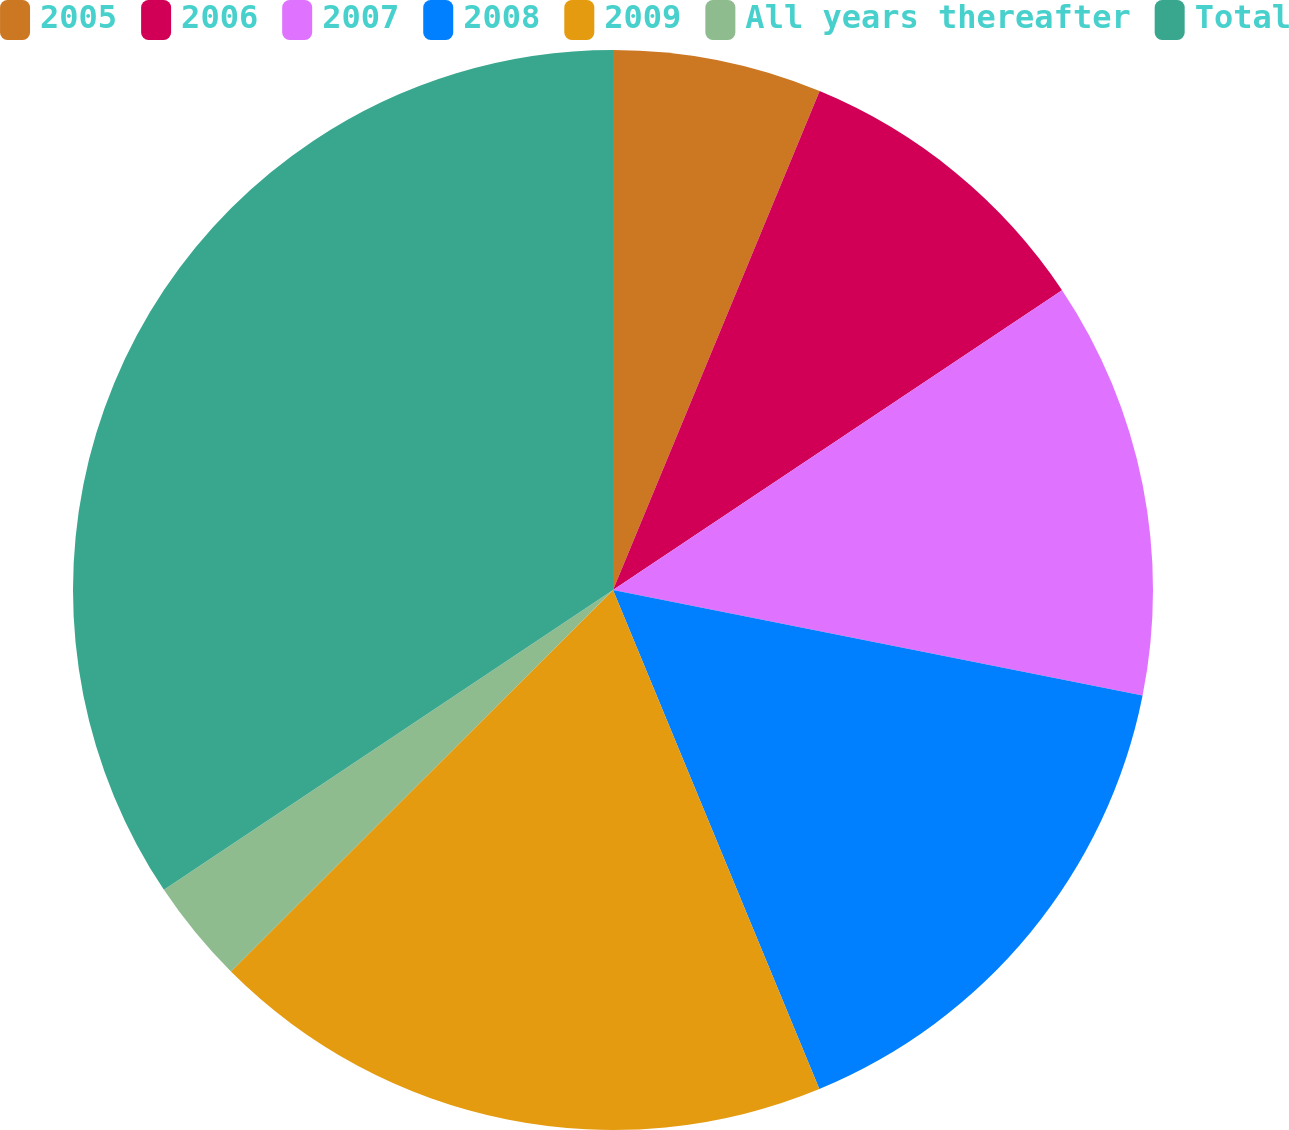Convert chart. <chart><loc_0><loc_0><loc_500><loc_500><pie_chart><fcel>2005<fcel>2006<fcel>2007<fcel>2008<fcel>2009<fcel>All years thereafter<fcel>Total<nl><fcel>6.25%<fcel>9.38%<fcel>12.5%<fcel>15.63%<fcel>18.75%<fcel>3.12%<fcel>34.37%<nl></chart> 